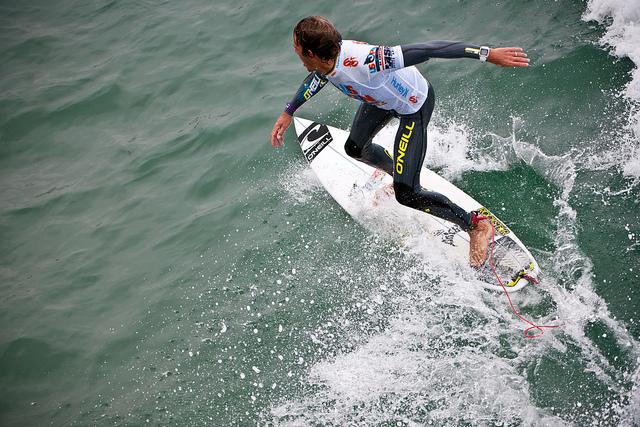Is the person wearing a wetsuit?
Write a very short answer. Yes. Is this man wearing a watch?
Answer briefly. Yes. Is this person athletic?
Answer briefly. Yes. Who is sponsoring the man's trousers?
Write a very short answer. O'neill. 